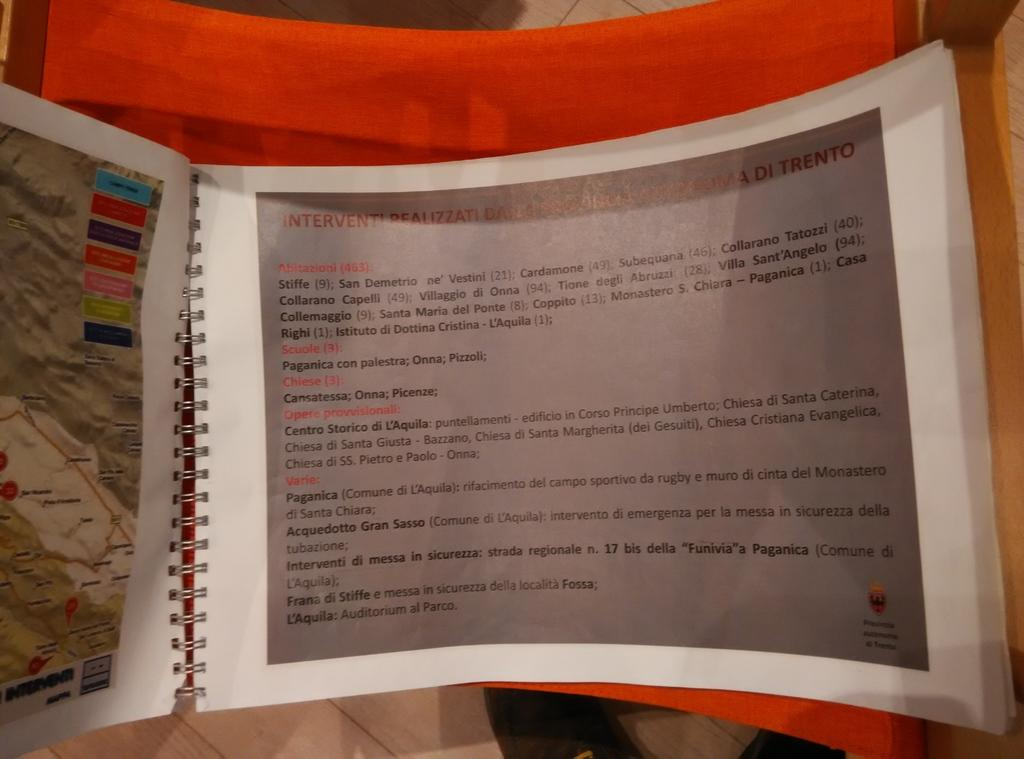<image>
Present a compact description of the photo's key features. a paper with the name Stiffe at the top of it 